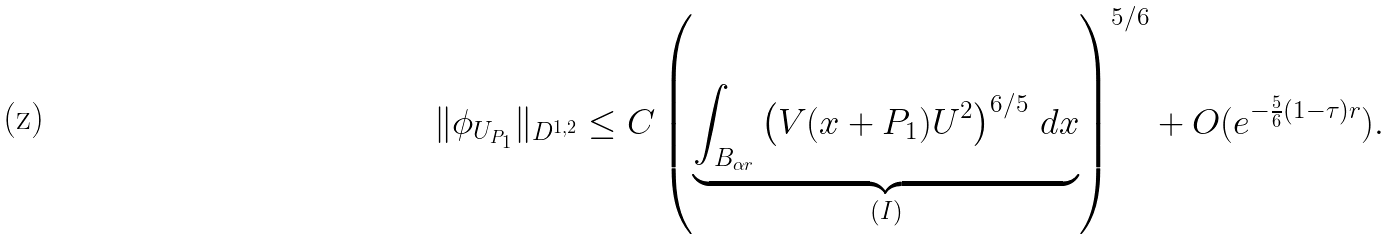<formula> <loc_0><loc_0><loc_500><loc_500>\| \phi _ { U _ { P _ { 1 } } } \| _ { D ^ { 1 , 2 } } \leq C \left ( \underbrace { \int _ { B _ { \alpha r } } \left ( V ( x + P _ { 1 } ) U ^ { 2 } \right ) ^ { 6 / 5 } \, d x } _ { ( I ) } \right ) ^ { 5 / 6 } + O ( e ^ { - \frac { 5 } { 6 } ( 1 - \tau ) r } ) .</formula> 